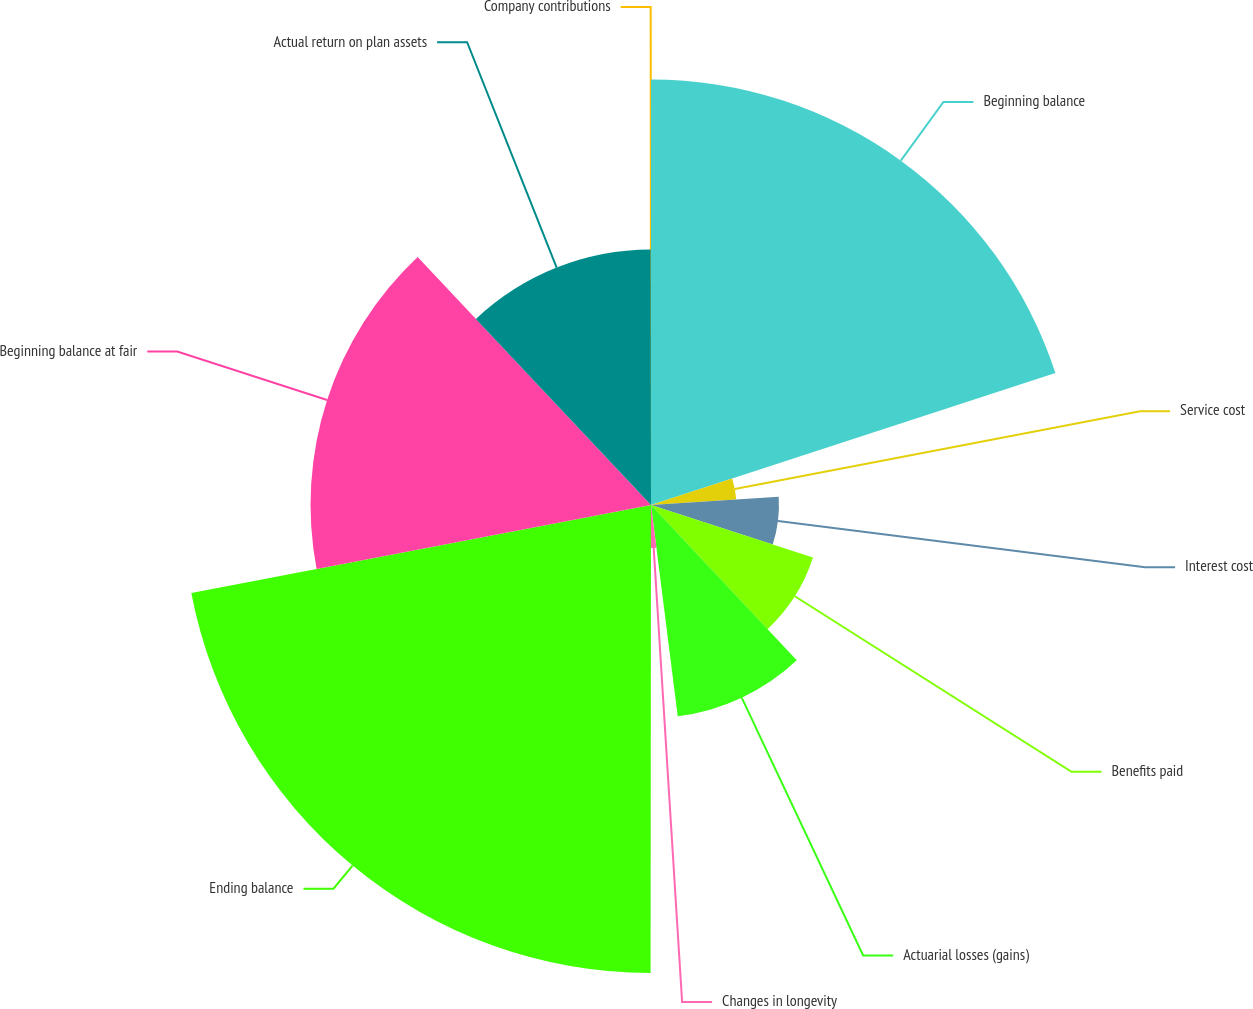<chart> <loc_0><loc_0><loc_500><loc_500><pie_chart><fcel>Beginning balance<fcel>Service cost<fcel>Interest cost<fcel>Benefits paid<fcel>Actuarial losses (gains)<fcel>Changes in longevity<fcel>Ending balance<fcel>Beginning balance at fair<fcel>Actual return on plan assets<fcel>Company contributions<nl><fcel>19.98%<fcel>4.01%<fcel>6.01%<fcel>8.0%<fcel>10.0%<fcel>2.02%<fcel>21.98%<fcel>15.99%<fcel>12.0%<fcel>0.02%<nl></chart> 